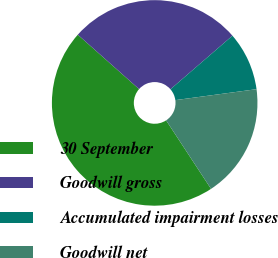<chart> <loc_0><loc_0><loc_500><loc_500><pie_chart><fcel>30 September<fcel>Goodwill gross<fcel>Accumulated impairment losses<fcel>Goodwill net<nl><fcel>45.79%<fcel>27.11%<fcel>9.21%<fcel>17.9%<nl></chart> 